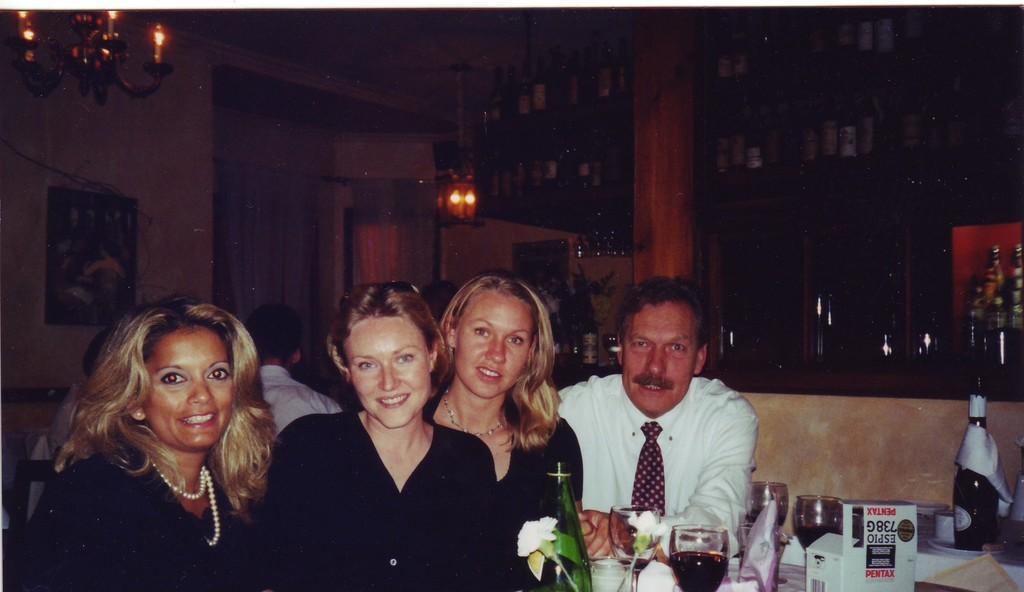How would you summarize this image in a sentence or two? In this image there are group of people posing for the picture. In front of them there is a table on which there are glasses,glass bottle,flower vase,wine bottle,plates,cups and tissue papers. In the background there are wine bottles kept in the racks. At the top there is a chandelier. To the wall there is a photo frame. 